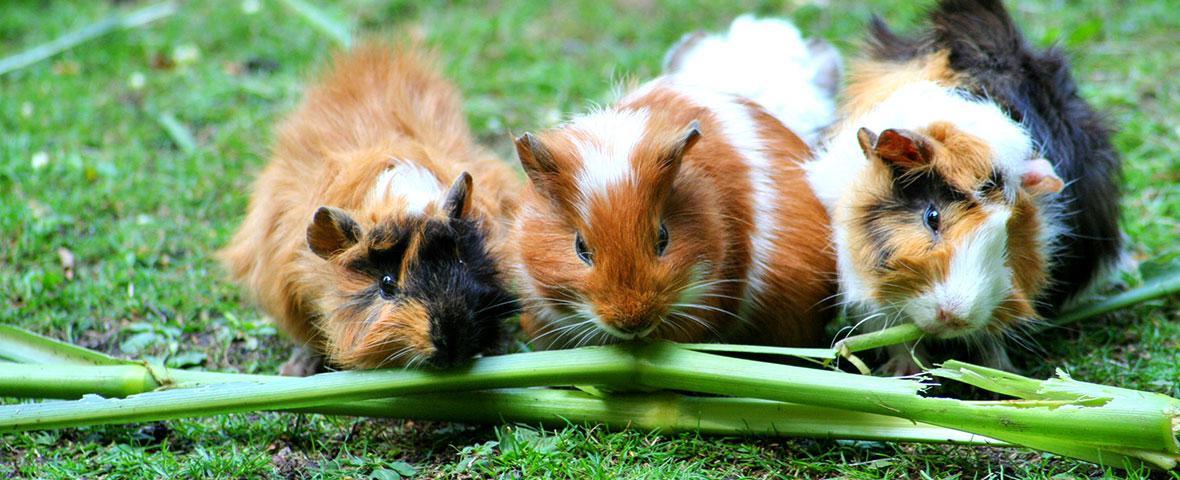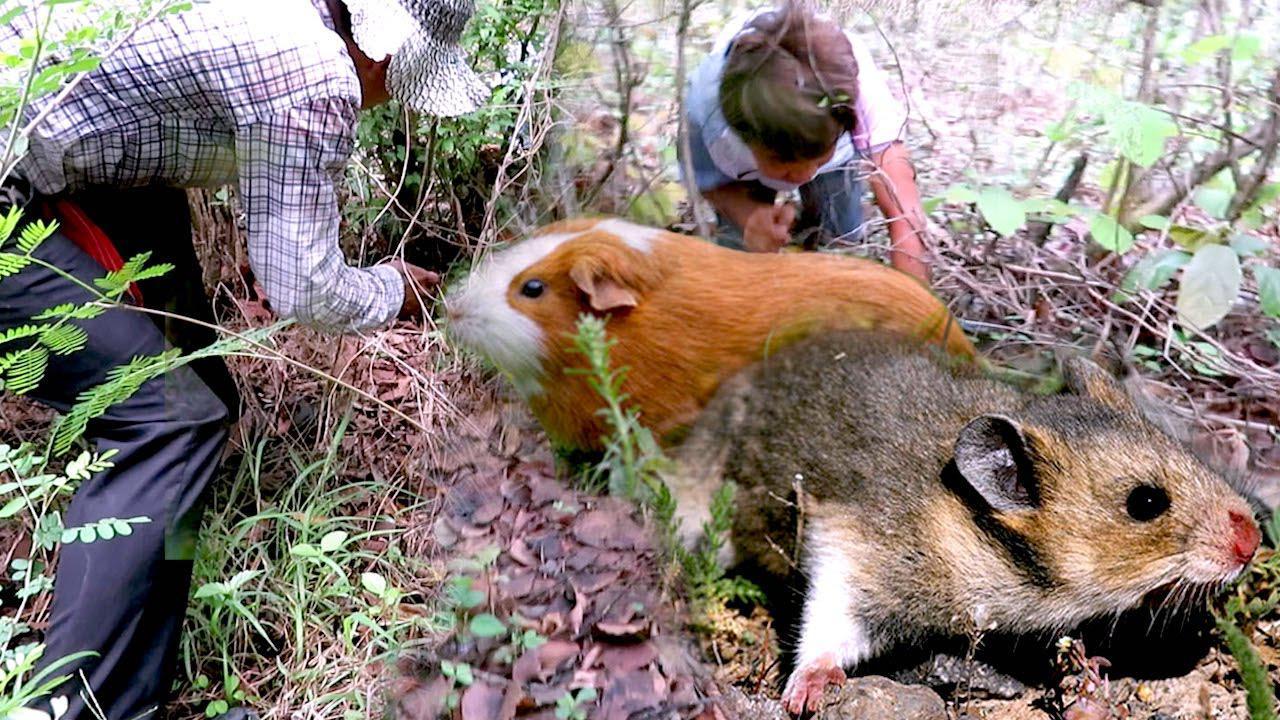The first image is the image on the left, the second image is the image on the right. Considering the images on both sides, is "the image on the right contains a flower" valid? Answer yes or no. No. 